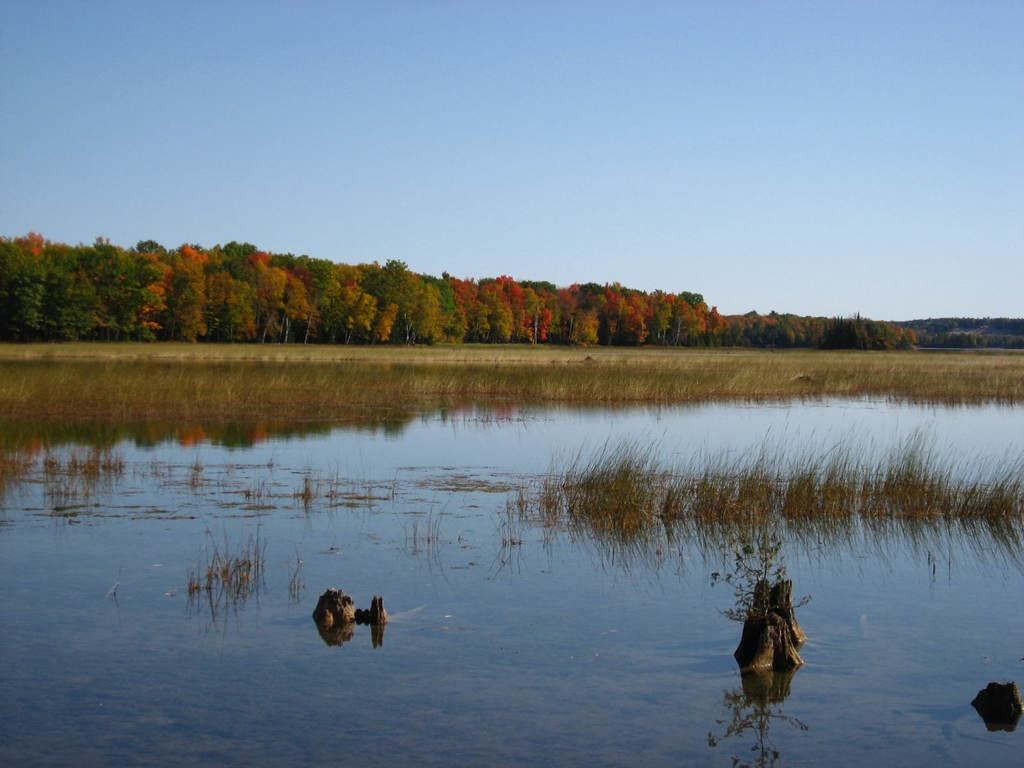What objects are in the water in the image? There are wooden sticks in the water in the image. What can be seen in the water besides the wooden sticks? The reflection of the sky is visible in the water. What type of vegetation is present in the image? There are trees and grass in the image. What part of the natural environment is visible in the image? The sky is visible in the image. What type of sugar is being used to sweeten the meal in the image? There is no meal or sugar present in the image; it features wooden sticks in the water and natural elements like trees, grass, and the sky. 